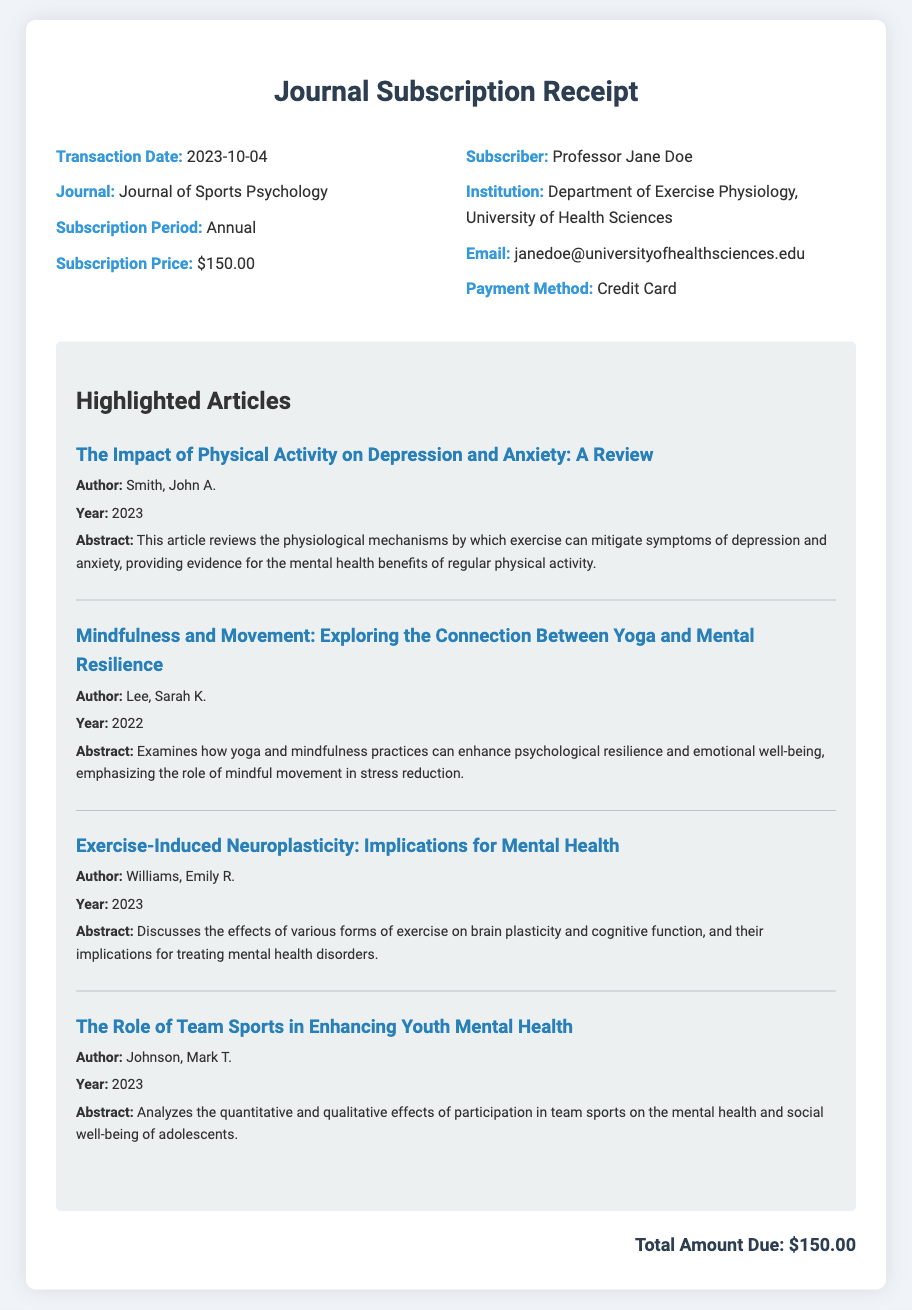What is the transaction date? The transaction date is listed in the document under receipt details.
Answer: 2023-10-04 Who is the subscriber? The subscriber's name is mentioned in the receipt details section.
Answer: Professor Jane Doe What is the subscription price? The subscription price is provided in the receipt details section of the document.
Answer: $150.00 How long is the subscription period? The duration of the subscription is specified in the document.
Answer: Annual What is the title of the first highlighted article? The first highlighted article's title can be found under the highlighted articles section.
Answer: The Impact of Physical Activity on Depression and Anxiety: A Review Which author wrote about yoga and mental resilience? The author discussing yoga and mental resilience is mentioned in the highlighted articles section.
Answer: Lee, Sarah K How many articles are highlighted in the document? The number of highlighted articles can be counted in the highlighted articles section.
Answer: Four What payment method was used for the subscription? The payment method for the subscription is listed in the receipt details.
Answer: Credit Card What is the total amount due? The total amount due is specified at the end of the document.
Answer: $150.00 